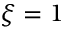<formula> <loc_0><loc_0><loc_500><loc_500>\xi = 1</formula> 